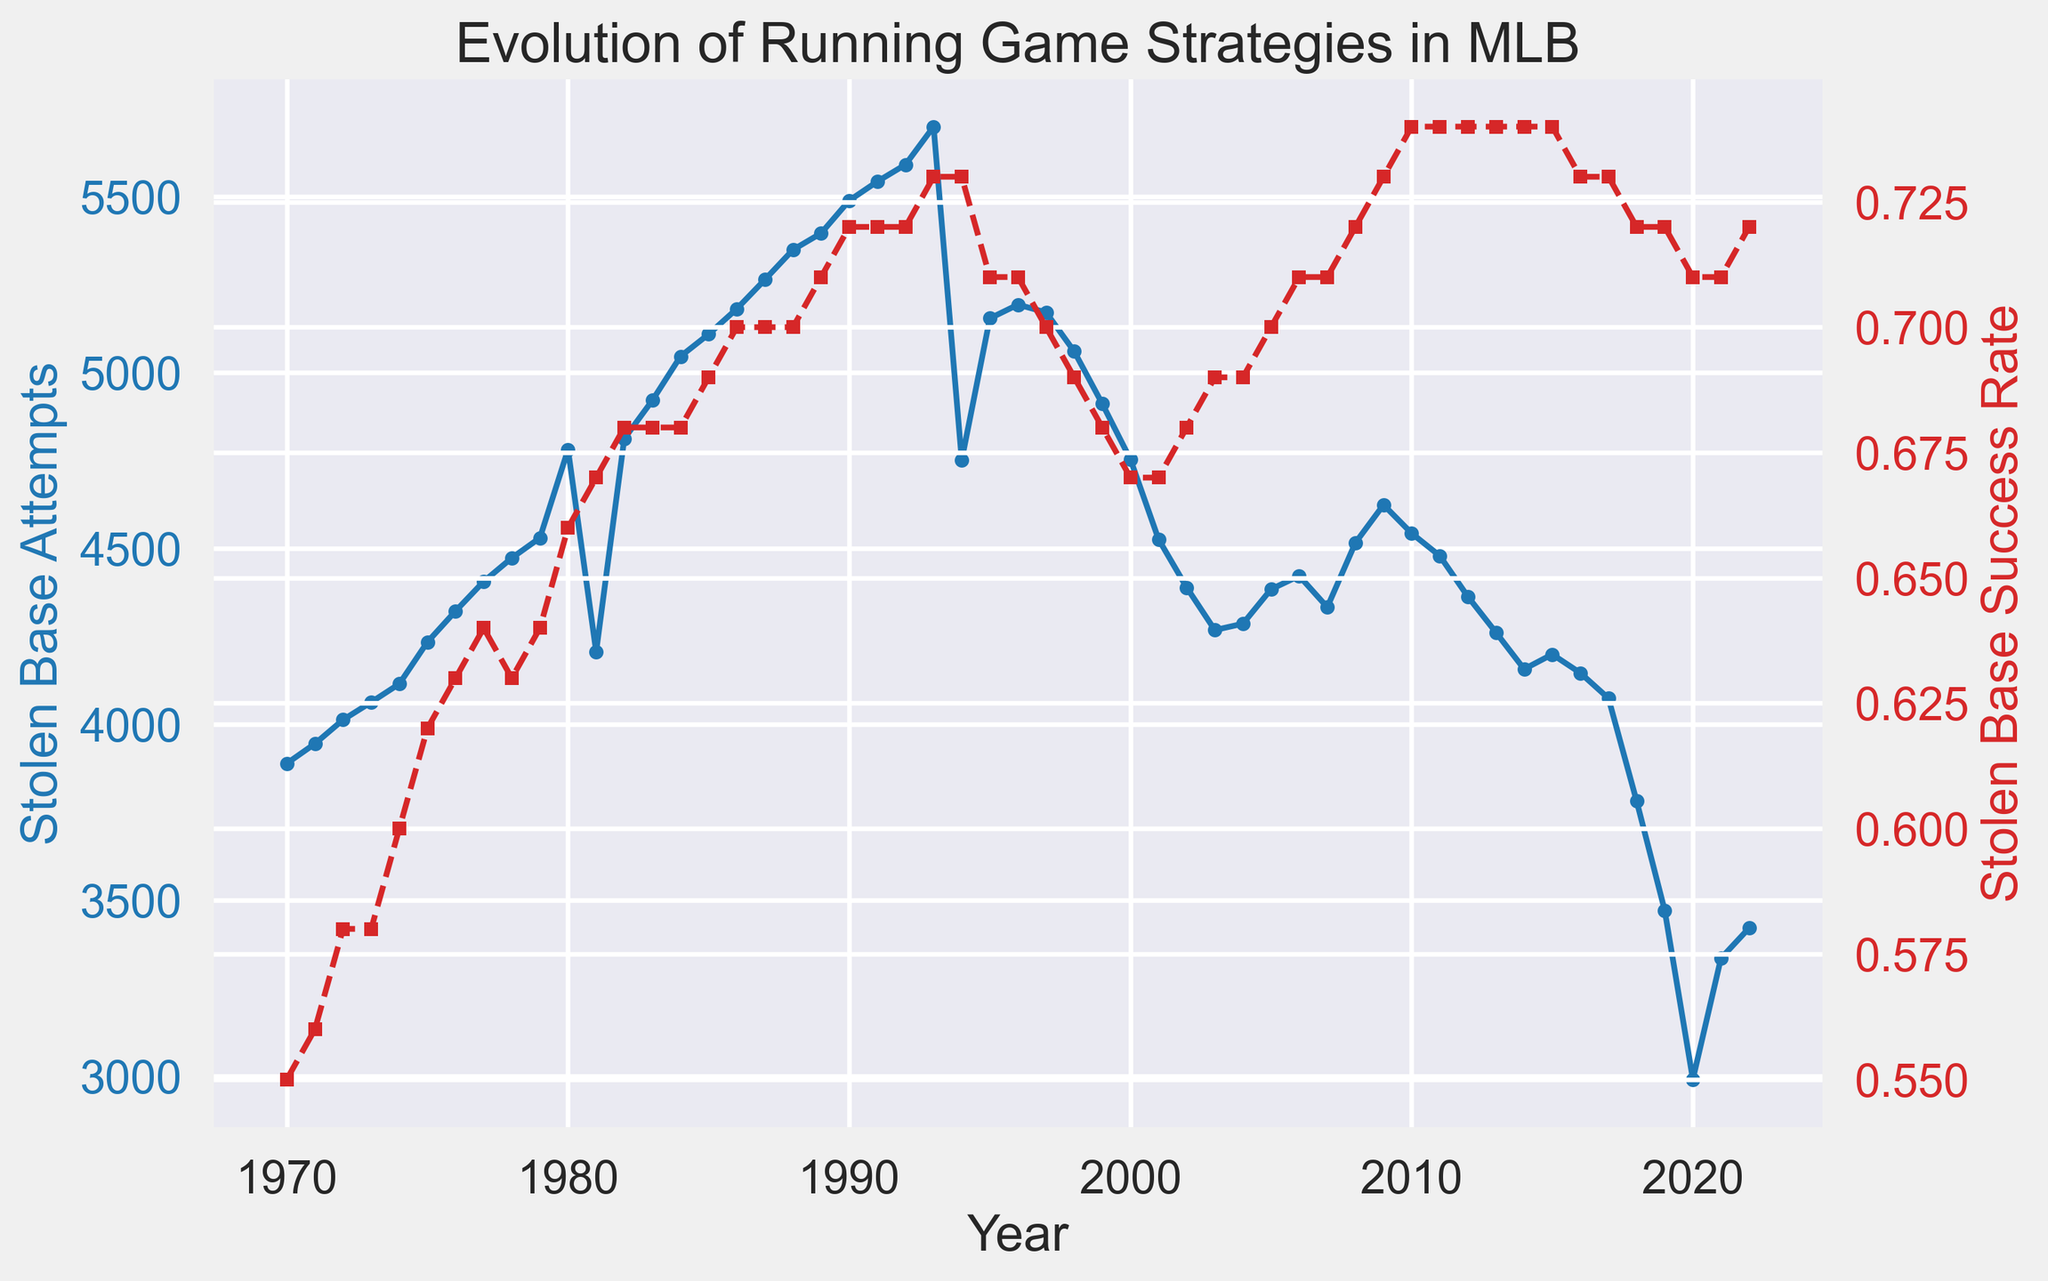When did stolen base attempts peak? By examining the blue line representing stolen base attempts on the graph, we can see that it reaches its highest point around the year 1993. This indicates the peak year for stolen base attempts.
Answer: 1993 When did the stolen base success rate reach its highest point? Looking at the red dashed line representing stolen base success rate, we observe the highest point around the year 2014, where the success rate reaches its maximum.
Answer: 2014 What is the difference in the stolen base success rate between 1980 and 2000? The success rate in 1980 is shown as 0.66, and in 2000 it is 0.67. Subtracting the former from the latter gives 0.67 - 0.66 = 0.01.
Answer: 0.01 Compare the trend of stolen base attempts to the trend of stolen base success rates from 1970 to 2022. There is a general increasing trend in both stolen base attempts and success rates from 1970 to the early 1990s. After the 1990s, attempts decline while the success rate remains relatively high and stable.
Answer: Increasing until the early 1990s, then decreasing attempts and stable high success rates By how much did the stolen base attempts decrease from their peak in 1993 to 2022? Stolen base attempts peaked at about 5698 in 1993 and decreased to around 3420 in 2022. The decrease is 5698 - 3420 = 2278.
Answer: 2278 Describe the change in stolen base success rate from 1970 to 2022. In 1970, the success rate was 0.55. By 2022, it had increased to 0.72. This shows a clear upward trend in the success rate over the period.
Answer: Increased from 0.55 to 0.72 What was the approximate stolen base success rate during the 1980s? Observing the red dashed line during the 1980s, the success rate ranged approximately between 0.66 and 0.72.
Answer: Between 0.66 and 0.72 In what year did the stolen base attempts drop below 4000 for the first time? Observing the blue line, the stolen base attempts dropped below 4000 in 2020.
Answer: 2020 